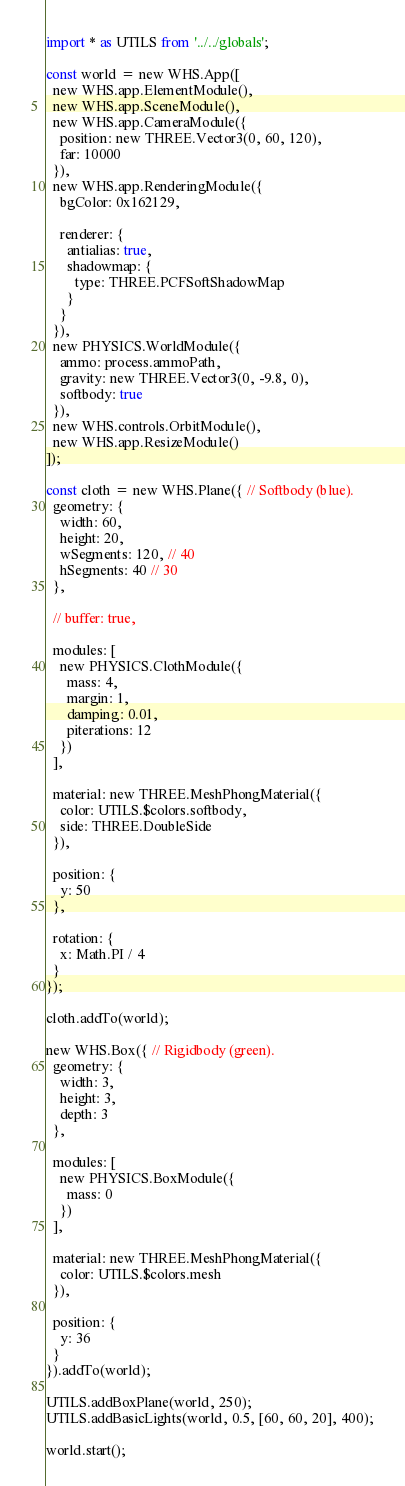Convert code to text. <code><loc_0><loc_0><loc_500><loc_500><_JavaScript_>import * as UTILS from '../../globals';

const world = new WHS.App([
  new WHS.app.ElementModule(),
  new WHS.app.SceneModule(),
  new WHS.app.CameraModule({
    position: new THREE.Vector3(0, 60, 120),
    far: 10000
  }),
  new WHS.app.RenderingModule({
    bgColor: 0x162129,

    renderer: {
      antialias: true,
      shadowmap: {
        type: THREE.PCFSoftShadowMap
      }
    }
  }),
  new PHYSICS.WorldModule({
    ammo: process.ammoPath,
    gravity: new THREE.Vector3(0, -9.8, 0),
    softbody: true
  }),
  new WHS.controls.OrbitModule(),
  new WHS.app.ResizeModule()
]);

const cloth = new WHS.Plane({ // Softbody (blue).
  geometry: {
    width: 60,
    height: 20,
    wSegments: 120, // 40
    hSegments: 40 // 30
  },

  // buffer: true,

  modules: [
    new PHYSICS.ClothModule({
      mass: 4,
      margin: 1,
      damping: 0.01,
      piterations: 12
    })
  ],

  material: new THREE.MeshPhongMaterial({
    color: UTILS.$colors.softbody,
    side: THREE.DoubleSide
  }),

  position: {
    y: 50
  },

  rotation: {
    x: Math.PI / 4
  }
});

cloth.addTo(world);

new WHS.Box({ // Rigidbody (green).
  geometry: {
    width: 3,
    height: 3,
    depth: 3
  },

  modules: [
    new PHYSICS.BoxModule({
      mass: 0
    })
  ],

  material: new THREE.MeshPhongMaterial({
    color: UTILS.$colors.mesh
  }),

  position: {
    y: 36
  }
}).addTo(world);

UTILS.addBoxPlane(world, 250);
UTILS.addBasicLights(world, 0.5, [60, 60, 20], 400);

world.start();
</code> 